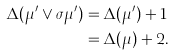<formula> <loc_0><loc_0><loc_500><loc_500>\Delta ( \mu ^ { \prime } \vee \sigma \mu ^ { \prime } ) & = \Delta ( \mu ^ { \prime } ) + 1 \\ & = \Delta ( \mu ) + 2 .</formula> 